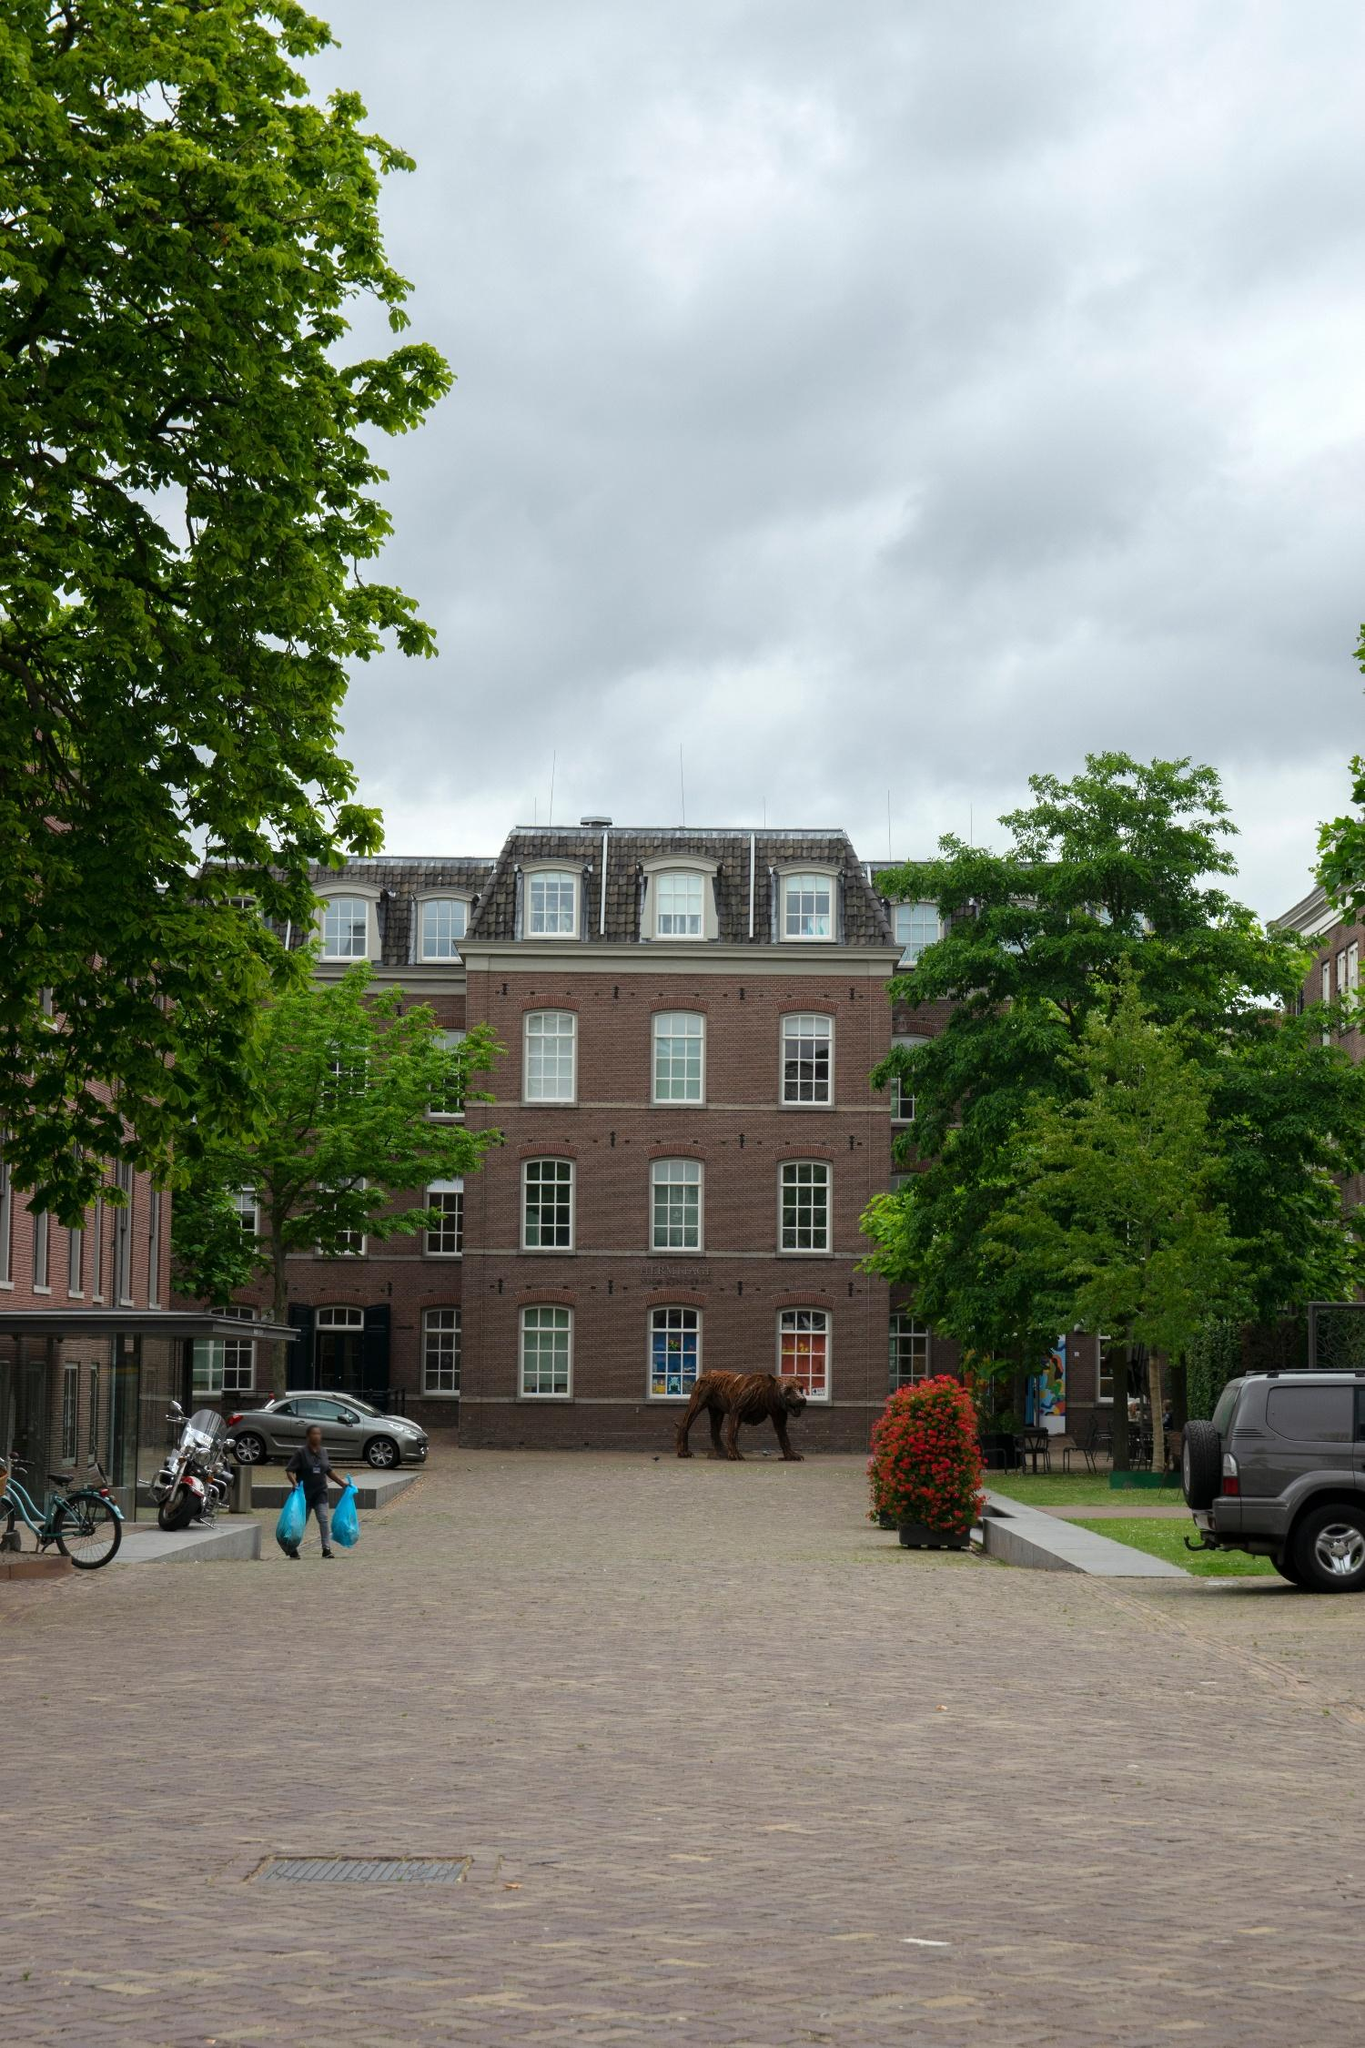Describe a realistic scenario of what could be going on? In a realistic scenario, the street is part of a historic district where residents appreciate the blend of tradition and art. The person walking with two blue bags might be returning from a nearby city's organic market. The parked cars hint at a community that values both modern conveniences and historical charm. The bear sculpture is an intentional art installation by a local artist, aiming to enrich the cultural ambience of the area. It's a typical overcast day, common in spring, making for a serene and picturesque urban landscape. 